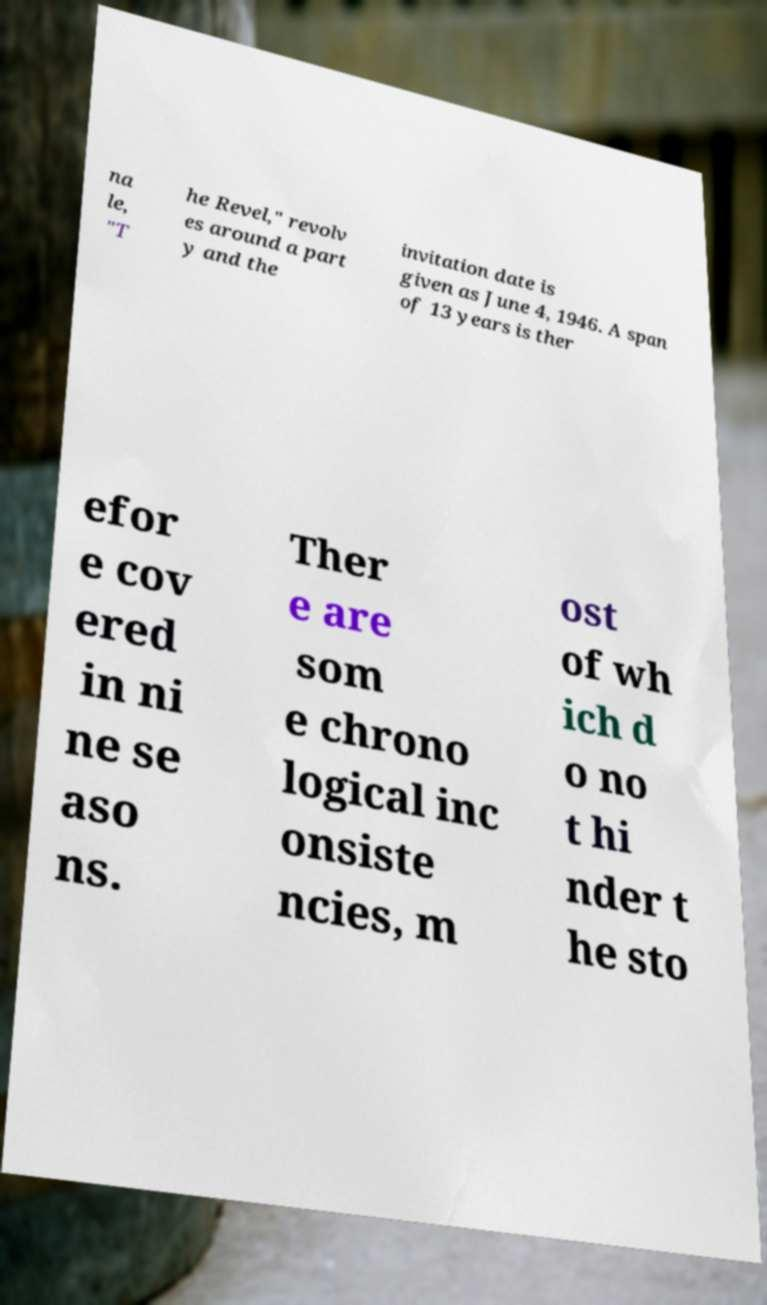I need the written content from this picture converted into text. Can you do that? na le, "T he Revel," revolv es around a part y and the invitation date is given as June 4, 1946. A span of 13 years is ther efor e cov ered in ni ne se aso ns. Ther e are som e chrono logical inc onsiste ncies, m ost of wh ich d o no t hi nder t he sto 